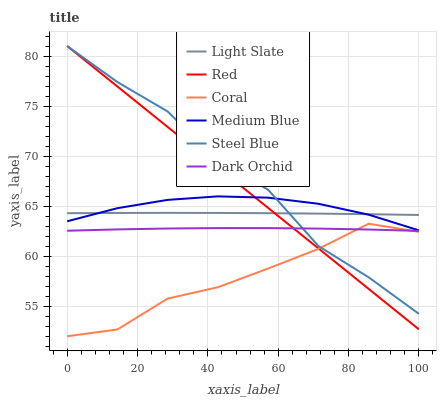Does Coral have the minimum area under the curve?
Answer yes or no. Yes. Does Steel Blue have the maximum area under the curve?
Answer yes or no. Yes. Does Medium Blue have the minimum area under the curve?
Answer yes or no. No. Does Medium Blue have the maximum area under the curve?
Answer yes or no. No. Is Red the smoothest?
Answer yes or no. Yes. Is Steel Blue the roughest?
Answer yes or no. Yes. Is Coral the smoothest?
Answer yes or no. No. Is Coral the roughest?
Answer yes or no. No. Does Medium Blue have the lowest value?
Answer yes or no. No. Does Coral have the highest value?
Answer yes or no. No. Is Dark Orchid less than Medium Blue?
Answer yes or no. Yes. Is Light Slate greater than Coral?
Answer yes or no. Yes. Does Dark Orchid intersect Medium Blue?
Answer yes or no. No. 